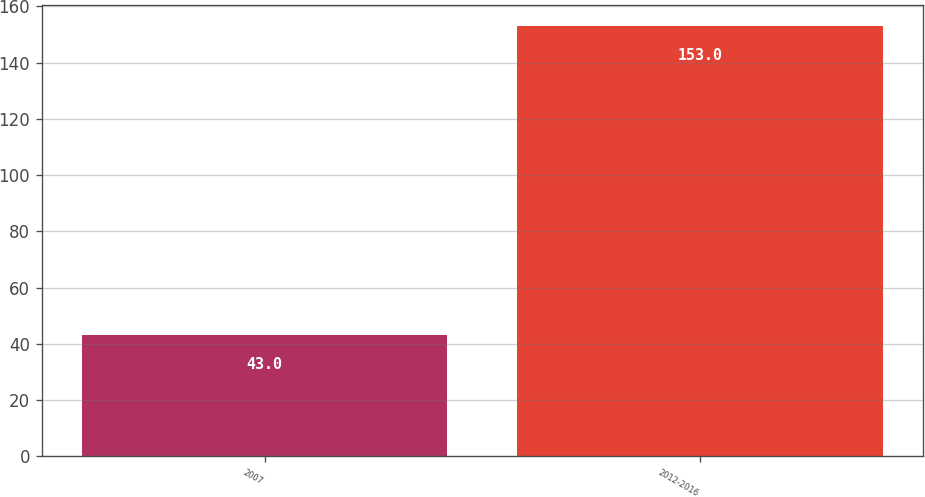<chart> <loc_0><loc_0><loc_500><loc_500><bar_chart><fcel>2007<fcel>2012-2016<nl><fcel>43<fcel>153<nl></chart> 